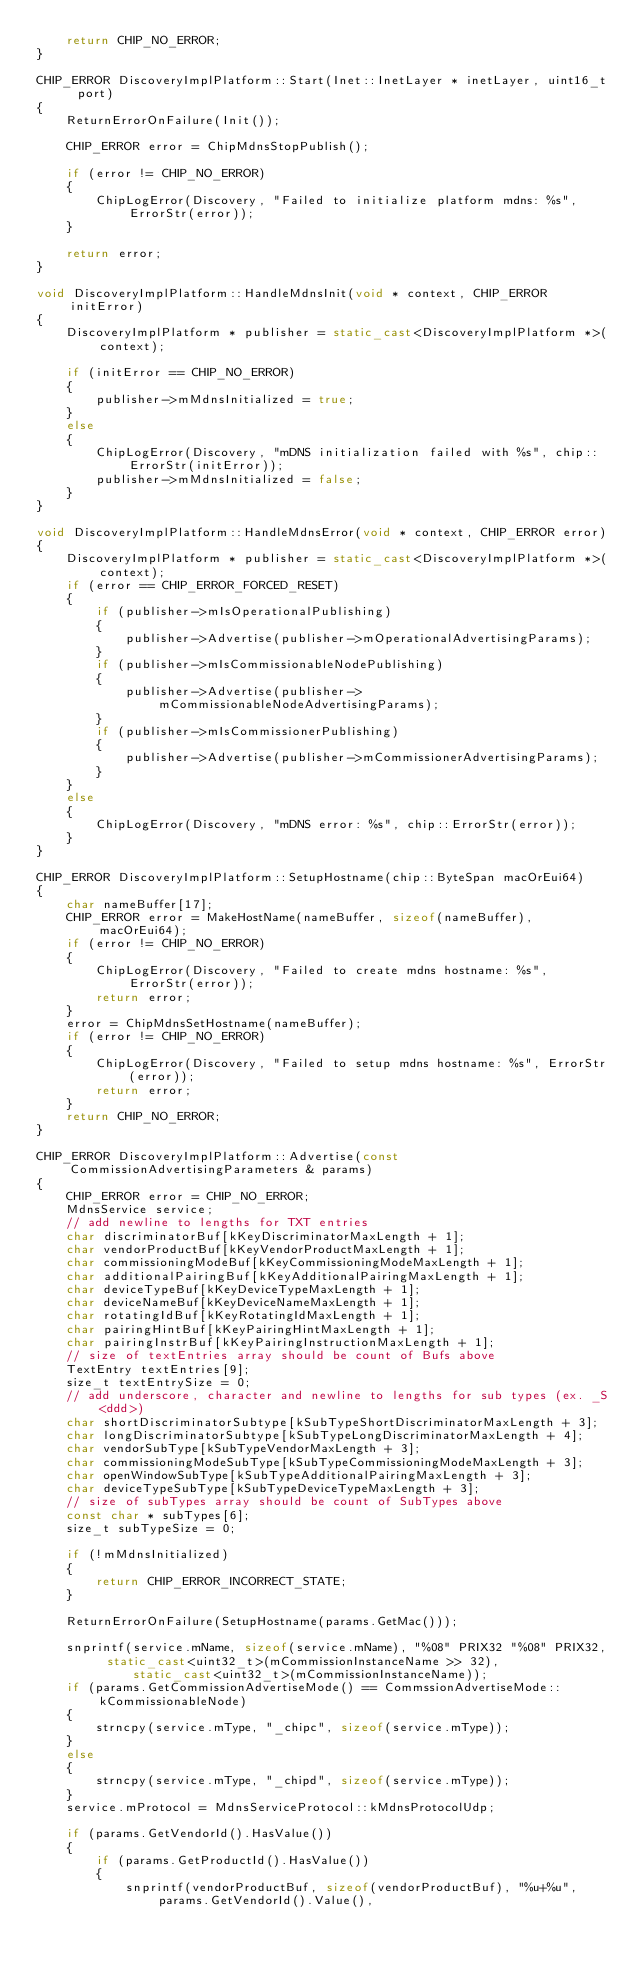<code> <loc_0><loc_0><loc_500><loc_500><_C++_>    return CHIP_NO_ERROR;
}

CHIP_ERROR DiscoveryImplPlatform::Start(Inet::InetLayer * inetLayer, uint16_t port)
{
    ReturnErrorOnFailure(Init());

    CHIP_ERROR error = ChipMdnsStopPublish();

    if (error != CHIP_NO_ERROR)
    {
        ChipLogError(Discovery, "Failed to initialize platform mdns: %s", ErrorStr(error));
    }

    return error;
}

void DiscoveryImplPlatform::HandleMdnsInit(void * context, CHIP_ERROR initError)
{
    DiscoveryImplPlatform * publisher = static_cast<DiscoveryImplPlatform *>(context);

    if (initError == CHIP_NO_ERROR)
    {
        publisher->mMdnsInitialized = true;
    }
    else
    {
        ChipLogError(Discovery, "mDNS initialization failed with %s", chip::ErrorStr(initError));
        publisher->mMdnsInitialized = false;
    }
}

void DiscoveryImplPlatform::HandleMdnsError(void * context, CHIP_ERROR error)
{
    DiscoveryImplPlatform * publisher = static_cast<DiscoveryImplPlatform *>(context);
    if (error == CHIP_ERROR_FORCED_RESET)
    {
        if (publisher->mIsOperationalPublishing)
        {
            publisher->Advertise(publisher->mOperationalAdvertisingParams);
        }
        if (publisher->mIsCommissionableNodePublishing)
        {
            publisher->Advertise(publisher->mCommissionableNodeAdvertisingParams);
        }
        if (publisher->mIsCommissionerPublishing)
        {
            publisher->Advertise(publisher->mCommissionerAdvertisingParams);
        }
    }
    else
    {
        ChipLogError(Discovery, "mDNS error: %s", chip::ErrorStr(error));
    }
}

CHIP_ERROR DiscoveryImplPlatform::SetupHostname(chip::ByteSpan macOrEui64)
{
    char nameBuffer[17];
    CHIP_ERROR error = MakeHostName(nameBuffer, sizeof(nameBuffer), macOrEui64);
    if (error != CHIP_NO_ERROR)
    {
        ChipLogError(Discovery, "Failed to create mdns hostname: %s", ErrorStr(error));
        return error;
    }
    error = ChipMdnsSetHostname(nameBuffer);
    if (error != CHIP_NO_ERROR)
    {
        ChipLogError(Discovery, "Failed to setup mdns hostname: %s", ErrorStr(error));
        return error;
    }
    return CHIP_NO_ERROR;
}

CHIP_ERROR DiscoveryImplPlatform::Advertise(const CommissionAdvertisingParameters & params)
{
    CHIP_ERROR error = CHIP_NO_ERROR;
    MdnsService service;
    // add newline to lengths for TXT entries
    char discriminatorBuf[kKeyDiscriminatorMaxLength + 1];
    char vendorProductBuf[kKeyVendorProductMaxLength + 1];
    char commissioningModeBuf[kKeyCommissioningModeMaxLength + 1];
    char additionalPairingBuf[kKeyAdditionalPairingMaxLength + 1];
    char deviceTypeBuf[kKeyDeviceTypeMaxLength + 1];
    char deviceNameBuf[kKeyDeviceNameMaxLength + 1];
    char rotatingIdBuf[kKeyRotatingIdMaxLength + 1];
    char pairingHintBuf[kKeyPairingHintMaxLength + 1];
    char pairingInstrBuf[kKeyPairingInstructionMaxLength + 1];
    // size of textEntries array should be count of Bufs above
    TextEntry textEntries[9];
    size_t textEntrySize = 0;
    // add underscore, character and newline to lengths for sub types (ex. _S<ddd>)
    char shortDiscriminatorSubtype[kSubTypeShortDiscriminatorMaxLength + 3];
    char longDiscriminatorSubtype[kSubTypeLongDiscriminatorMaxLength + 4];
    char vendorSubType[kSubTypeVendorMaxLength + 3];
    char commissioningModeSubType[kSubTypeCommissioningModeMaxLength + 3];
    char openWindowSubType[kSubTypeAdditionalPairingMaxLength + 3];
    char deviceTypeSubType[kSubTypeDeviceTypeMaxLength + 3];
    // size of subTypes array should be count of SubTypes above
    const char * subTypes[6];
    size_t subTypeSize = 0;

    if (!mMdnsInitialized)
    {
        return CHIP_ERROR_INCORRECT_STATE;
    }

    ReturnErrorOnFailure(SetupHostname(params.GetMac()));

    snprintf(service.mName, sizeof(service.mName), "%08" PRIX32 "%08" PRIX32, static_cast<uint32_t>(mCommissionInstanceName >> 32),
             static_cast<uint32_t>(mCommissionInstanceName));
    if (params.GetCommissionAdvertiseMode() == CommssionAdvertiseMode::kCommissionableNode)
    {
        strncpy(service.mType, "_chipc", sizeof(service.mType));
    }
    else
    {
        strncpy(service.mType, "_chipd", sizeof(service.mType));
    }
    service.mProtocol = MdnsServiceProtocol::kMdnsProtocolUdp;

    if (params.GetVendorId().HasValue())
    {
        if (params.GetProductId().HasValue())
        {
            snprintf(vendorProductBuf, sizeof(vendorProductBuf), "%u+%u", params.GetVendorId().Value(),</code> 